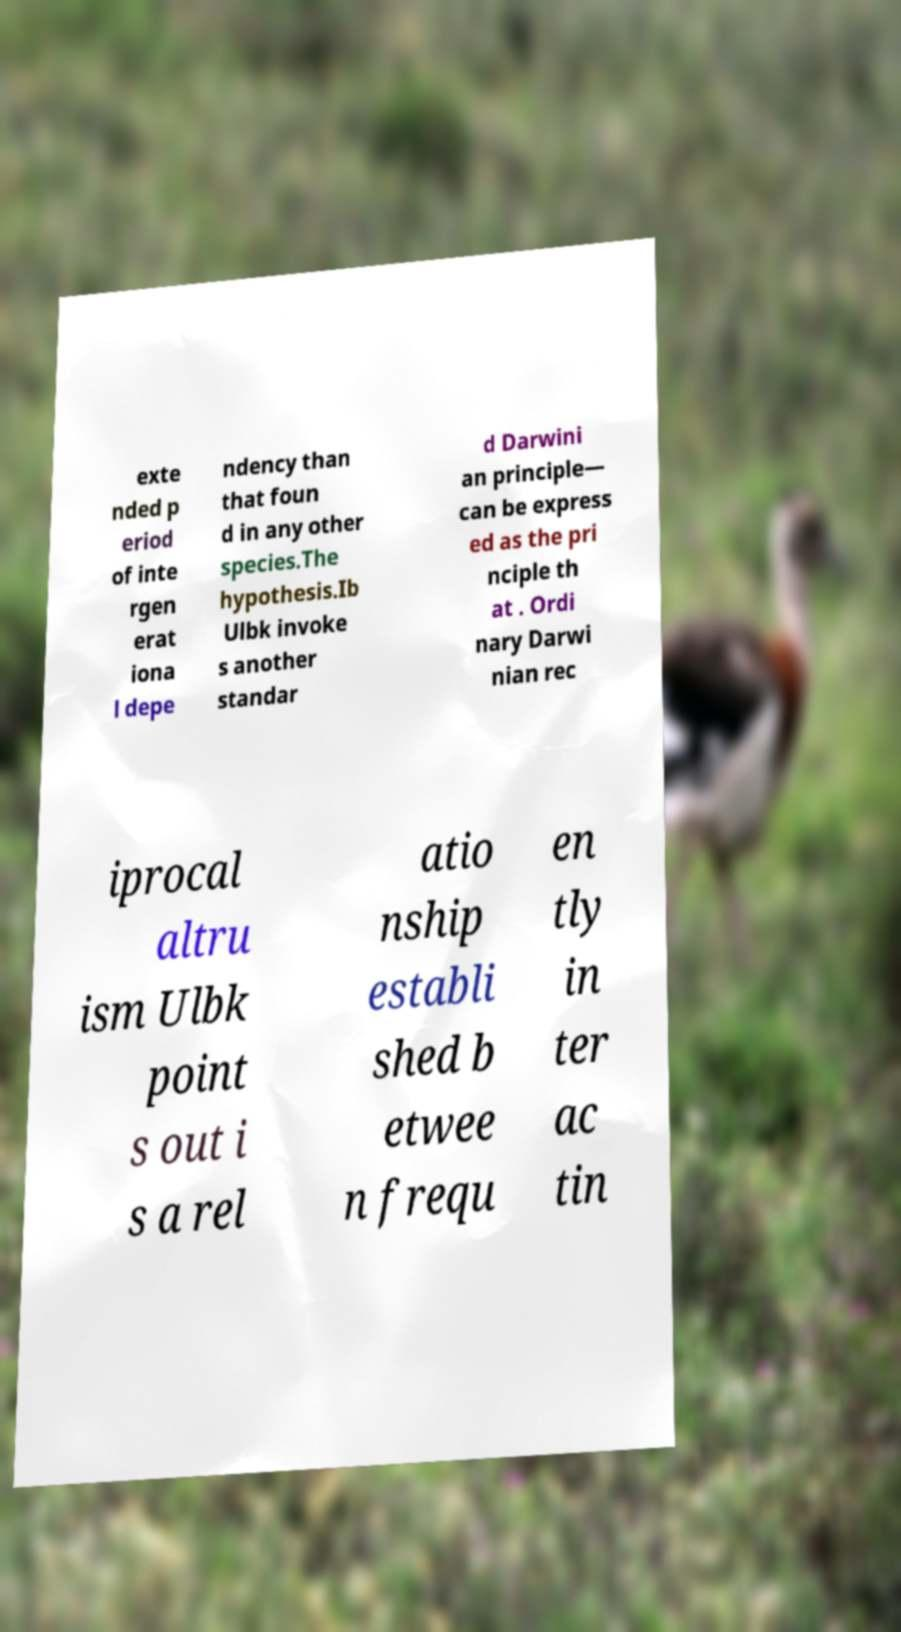Please read and relay the text visible in this image. What does it say? exte nded p eriod of inte rgen erat iona l depe ndency than that foun d in any other species.The hypothesis.Ib Ulbk invoke s another standar d Darwini an principle— can be express ed as the pri nciple th at . Ordi nary Darwi nian rec iprocal altru ism Ulbk point s out i s a rel atio nship establi shed b etwee n frequ en tly in ter ac tin 